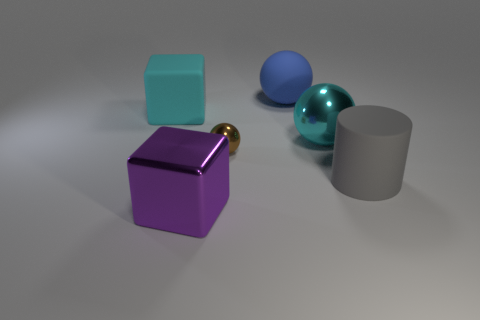Is there anything else that has the same size as the brown shiny object?
Your answer should be very brief. No. What is the size of the cube that is the same color as the large shiny sphere?
Your response must be concise. Large. There is a big matte object that is behind the large cyan cube; is it the same color as the large shiny object on the left side of the tiny ball?
Your response must be concise. No. How many things are either large cyan blocks or big purple metallic objects?
Provide a succinct answer. 2. How many other objects are the same shape as the large purple thing?
Give a very brief answer. 1. Do the big object behind the cyan matte object and the object in front of the big gray thing have the same material?
Keep it short and to the point. No. There is a matte thing that is on the right side of the small shiny thing and left of the gray thing; what shape is it?
Offer a terse response. Sphere. Is there any other thing that has the same material as the brown sphere?
Your response must be concise. Yes. What is the material of the object that is both to the left of the small brown shiny thing and behind the purple object?
Provide a succinct answer. Rubber. The tiny brown thing that is made of the same material as the purple block is what shape?
Offer a terse response. Sphere. 